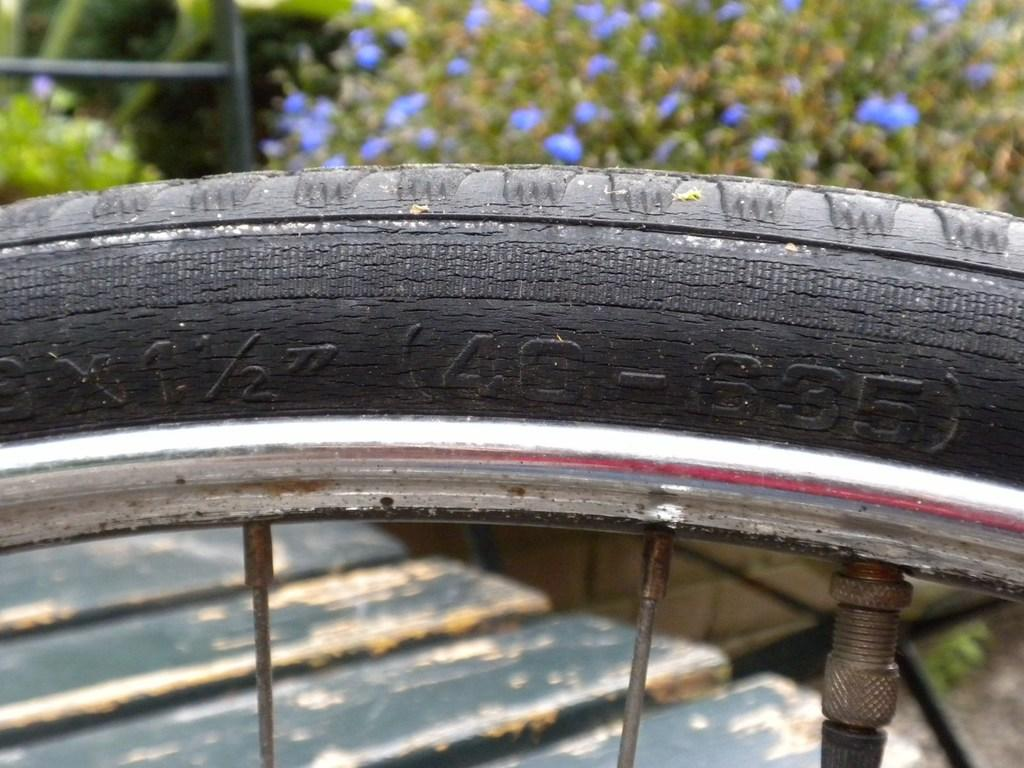What is the main subject of the image? The main subject of the image is a cycle tube. What other parts of the cycle can be seen in the image? There are cycle spokes visible in the image. What can be seen in the background of the image? There are trees and a walkway in the background of the image. What is the color of the walkway? The walkway is in a wooden color. What type of cream can be seen on the face of the person in the image? There is no person present in the image, and therefore no face or cream can be observed. What color crayon is being used to draw on the cycle tube in the image? There is no crayon present in the image, and the cycle tube is not being drawn on. 